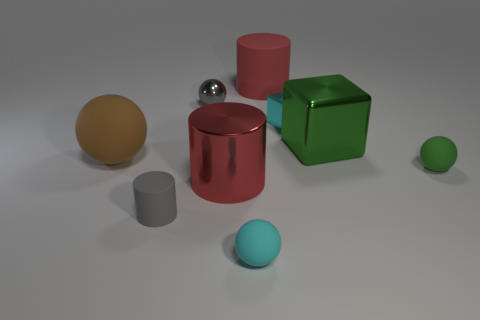Subtract all big cylinders. How many cylinders are left? 1 Subtract all cyan blocks. How many blocks are left? 1 Subtract all gray cubes. How many red cylinders are left? 2 Add 1 large cyan matte blocks. How many objects exist? 10 Subtract all blocks. How many objects are left? 7 Subtract 1 cylinders. How many cylinders are left? 2 Subtract all red cylinders. Subtract all purple blocks. How many cylinders are left? 1 Subtract all big red things. Subtract all green spheres. How many objects are left? 6 Add 7 large red metallic cylinders. How many large red metallic cylinders are left? 8 Add 2 small red matte spheres. How many small red matte spheres exist? 2 